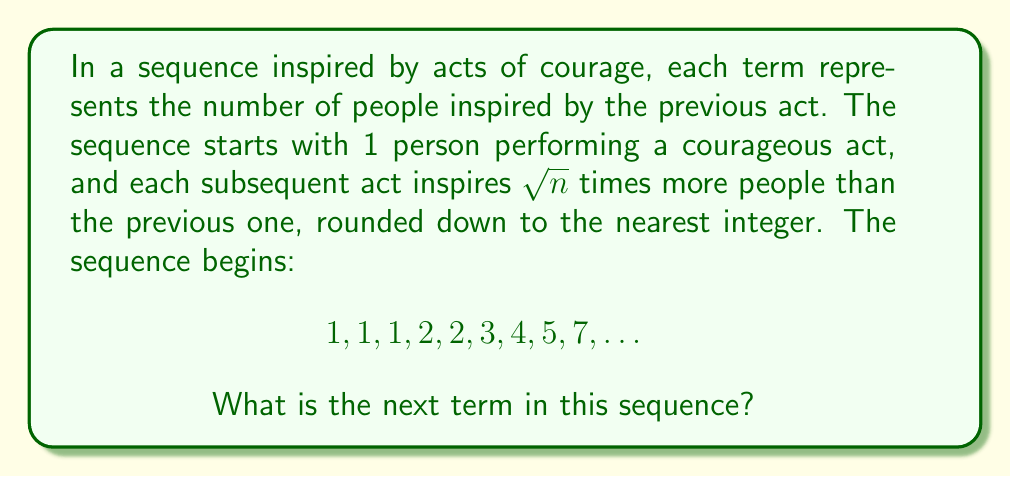Teach me how to tackle this problem. Let's analyze the sequence step-by-step:

1) The first term is 1, representing the initial courageous act.

2) For each subsequent term, we multiply the previous term by $\sqrt{n}$, where $n$ is the position of the term we're calculating, and round down to the nearest integer.

3) Let's calculate each term:
   - 2nd term: $1 \times \sqrt{2} \approx 1.41$, rounded down to 1
   - 3rd term: $1 \times \sqrt{3} \approx 1.73$, rounded down to 1
   - 4th term: $1 \times \sqrt{4} = 2$
   - 5th term: $2 \times \sqrt{5} \approx 4.47$, rounded down to 2
   - 6th term: $2 \times \sqrt{6} \approx 4.90$, rounded down to 3
   - 7th term: $3 \times \sqrt{7} \approx 7.94$, rounded down to 4
   - 8th term: $4 \times \sqrt{8} \approx 11.31$, rounded down to 5
   - 9th term: $5 \times \sqrt{9} = 15$, rounded down to 7

4) To find the 10th term, we calculate:
   $7 \times \sqrt{10} \approx 22.14$

5) Rounding down, we get 22.

Therefore, the 10th term in the sequence is 22.
Answer: 22 